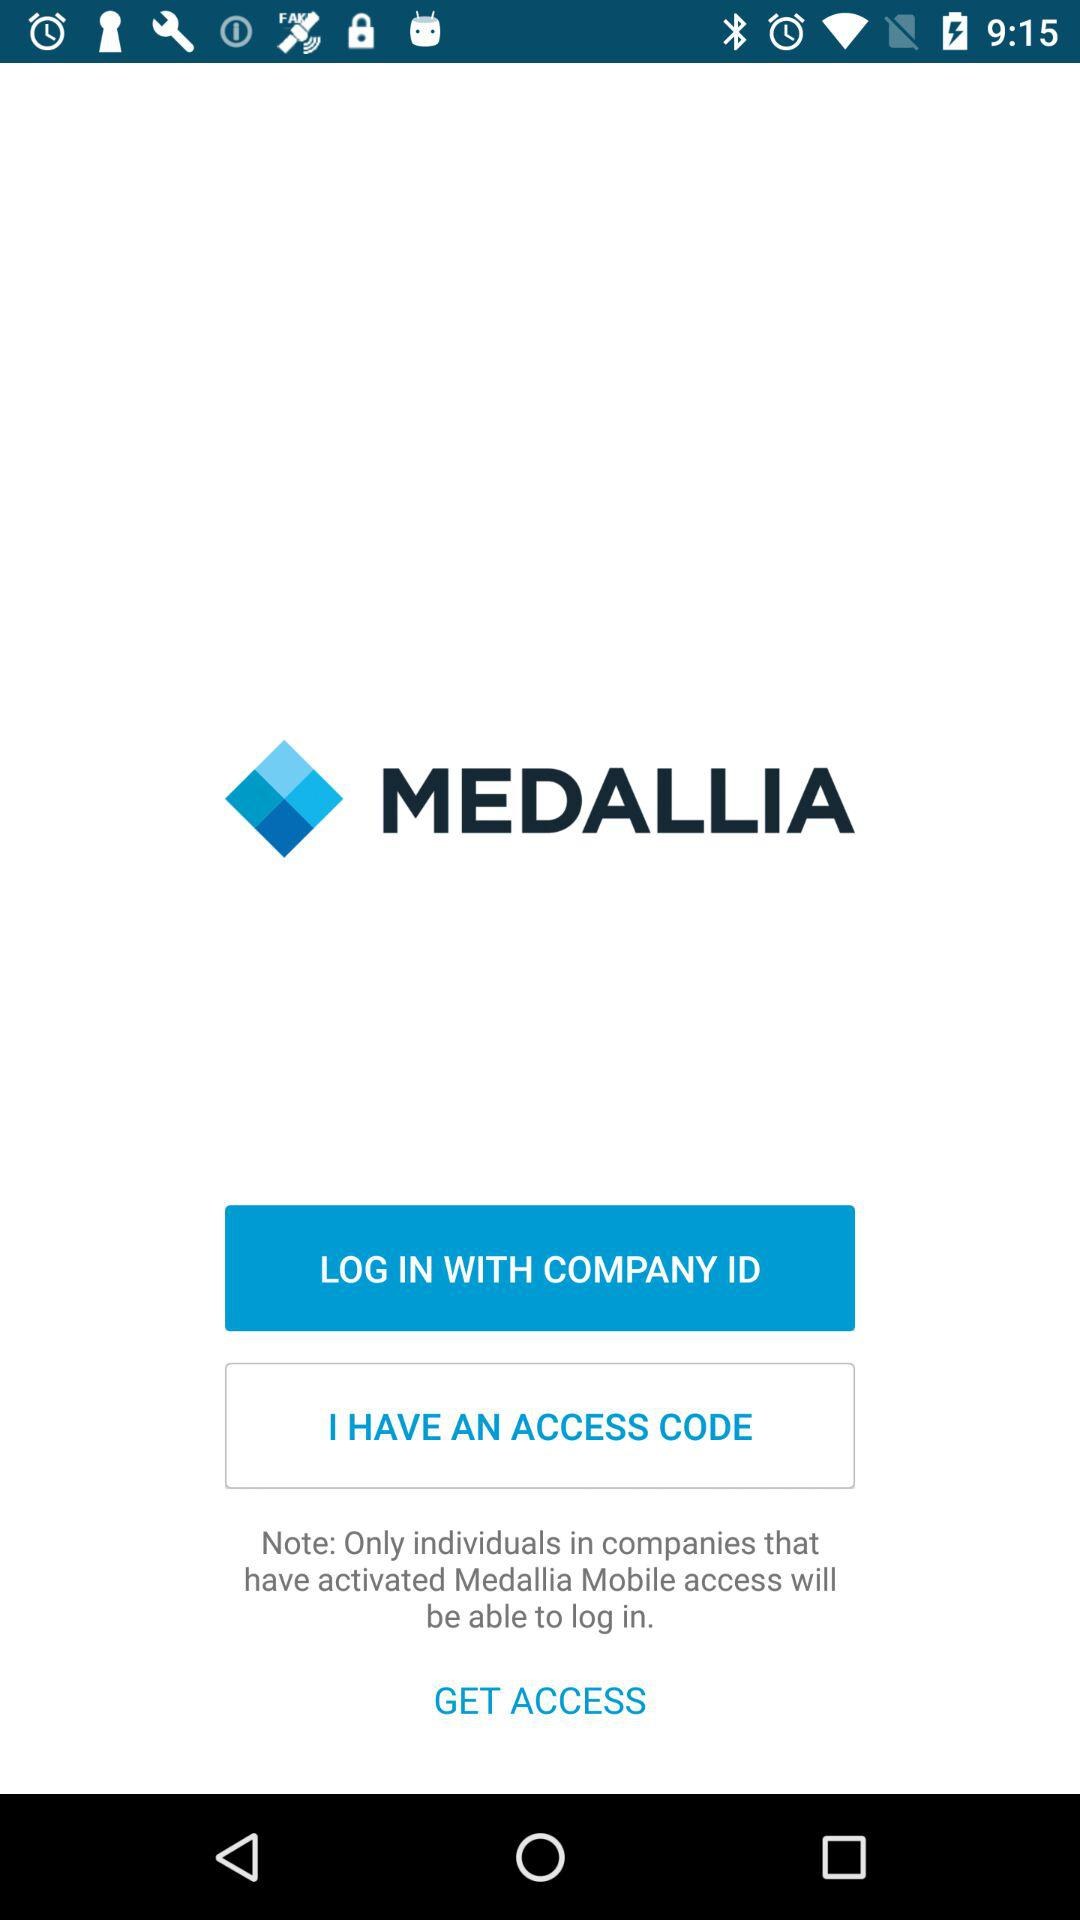How can we log in? You can log in with the company ID. 